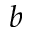<formula> <loc_0><loc_0><loc_500><loc_500>b</formula> 